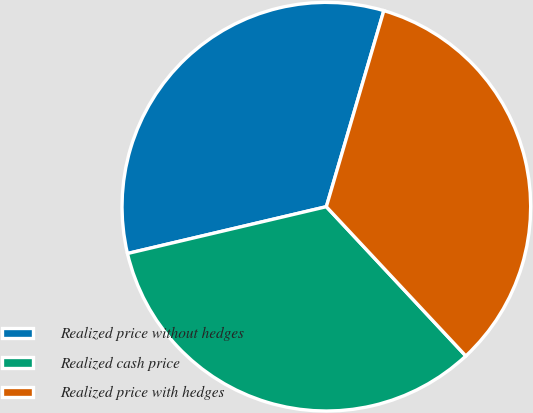<chart> <loc_0><loc_0><loc_500><loc_500><pie_chart><fcel>Realized price without hedges<fcel>Realized cash price<fcel>Realized price with hedges<nl><fcel>33.22%<fcel>33.28%<fcel>33.5%<nl></chart> 